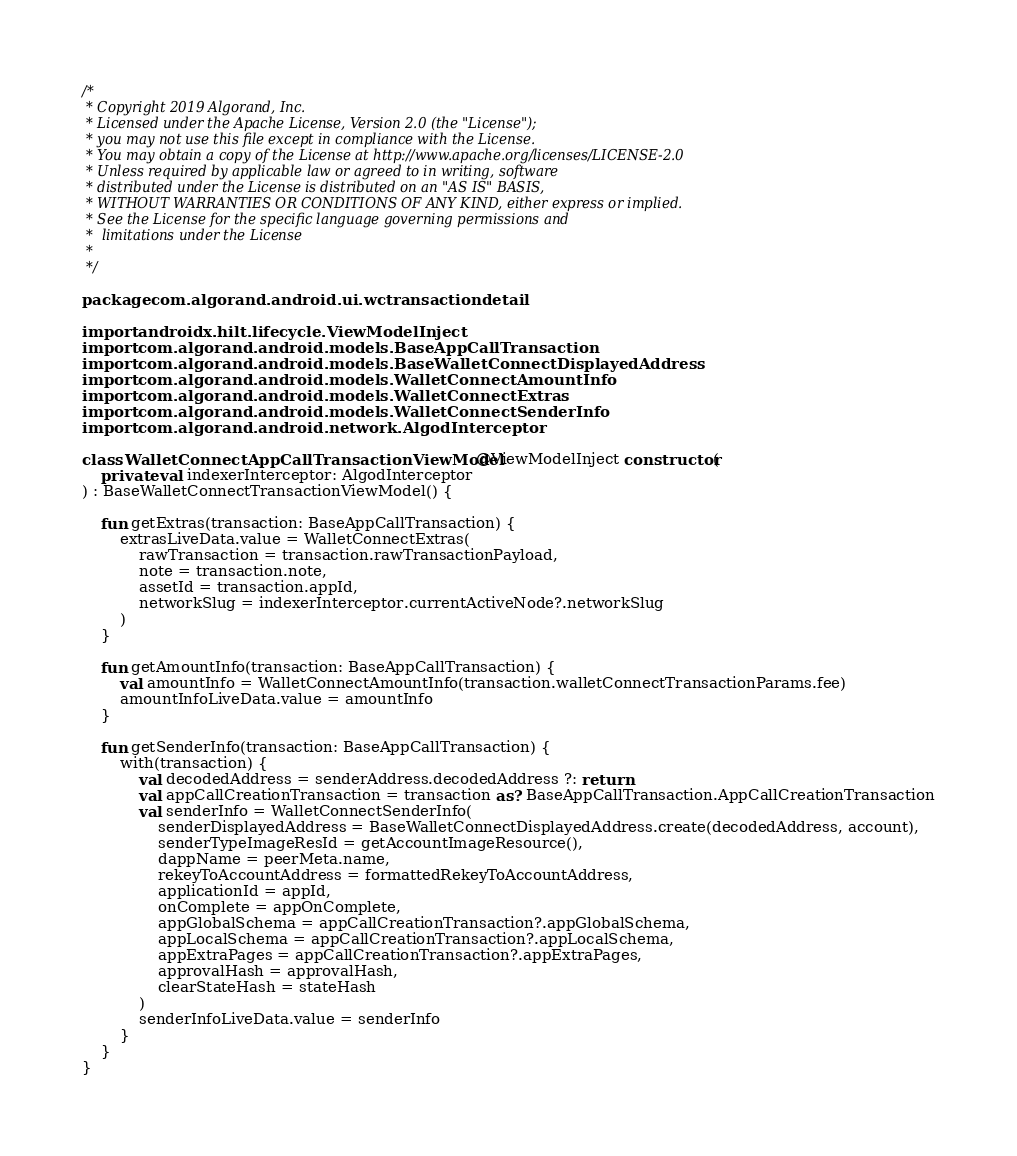<code> <loc_0><loc_0><loc_500><loc_500><_Kotlin_>/*
 * Copyright 2019 Algorand, Inc.
 * Licensed under the Apache License, Version 2.0 (the "License");
 * you may not use this file except in compliance with the License.
 * You may obtain a copy of the License at http://www.apache.org/licenses/LICENSE-2.0
 * Unless required by applicable law or agreed to in writing, software
 * distributed under the License is distributed on an "AS IS" BASIS,
 * WITHOUT WARRANTIES OR CONDITIONS OF ANY KIND, either express or implied.
 * See the License for the specific language governing permissions and
 *  limitations under the License
 *
 */

package com.algorand.android.ui.wctransactiondetail

import androidx.hilt.lifecycle.ViewModelInject
import com.algorand.android.models.BaseAppCallTransaction
import com.algorand.android.models.BaseWalletConnectDisplayedAddress
import com.algorand.android.models.WalletConnectAmountInfo
import com.algorand.android.models.WalletConnectExtras
import com.algorand.android.models.WalletConnectSenderInfo
import com.algorand.android.network.AlgodInterceptor

class WalletConnectAppCallTransactionViewModel @ViewModelInject constructor(
    private val indexerInterceptor: AlgodInterceptor
) : BaseWalletConnectTransactionViewModel() {

    fun getExtras(transaction: BaseAppCallTransaction) {
        extrasLiveData.value = WalletConnectExtras(
            rawTransaction = transaction.rawTransactionPayload,
            note = transaction.note,
            assetId = transaction.appId,
            networkSlug = indexerInterceptor.currentActiveNode?.networkSlug
        )
    }

    fun getAmountInfo(transaction: BaseAppCallTransaction) {
        val amountInfo = WalletConnectAmountInfo(transaction.walletConnectTransactionParams.fee)
        amountInfoLiveData.value = amountInfo
    }

    fun getSenderInfo(transaction: BaseAppCallTransaction) {
        with(transaction) {
            val decodedAddress = senderAddress.decodedAddress ?: return
            val appCallCreationTransaction = transaction as? BaseAppCallTransaction.AppCallCreationTransaction
            val senderInfo = WalletConnectSenderInfo(
                senderDisplayedAddress = BaseWalletConnectDisplayedAddress.create(decodedAddress, account),
                senderTypeImageResId = getAccountImageResource(),
                dappName = peerMeta.name,
                rekeyToAccountAddress = formattedRekeyToAccountAddress,
                applicationId = appId,
                onComplete = appOnComplete,
                appGlobalSchema = appCallCreationTransaction?.appGlobalSchema,
                appLocalSchema = appCallCreationTransaction?.appLocalSchema,
                appExtraPages = appCallCreationTransaction?.appExtraPages,
                approvalHash = approvalHash,
                clearStateHash = stateHash
            )
            senderInfoLiveData.value = senderInfo
        }
    }
}
</code> 